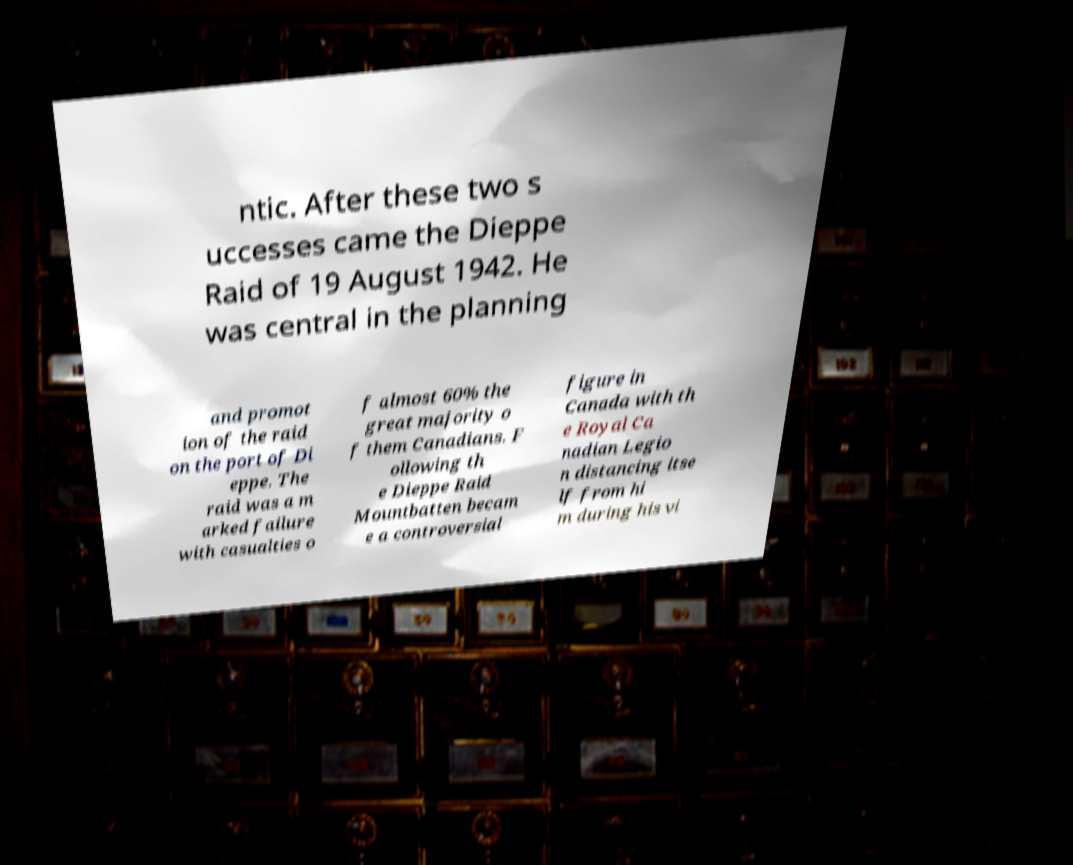Can you accurately transcribe the text from the provided image for me? ntic. After these two s uccesses came the Dieppe Raid of 19 August 1942. He was central in the planning and promot ion of the raid on the port of Di eppe. The raid was a m arked failure with casualties o f almost 60% the great majority o f them Canadians. F ollowing th e Dieppe Raid Mountbatten becam e a controversial figure in Canada with th e Royal Ca nadian Legio n distancing itse lf from hi m during his vi 